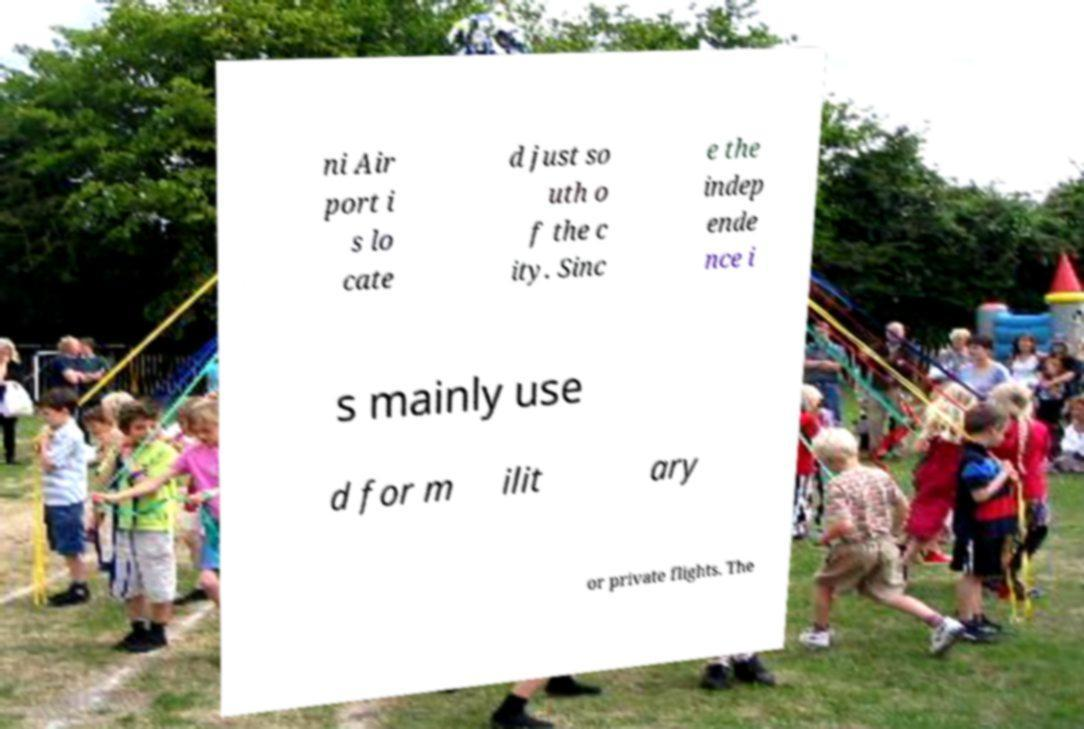What messages or text are displayed in this image? I need them in a readable, typed format. ni Air port i s lo cate d just so uth o f the c ity. Sinc e the indep ende nce i s mainly use d for m ilit ary or private flights. The 